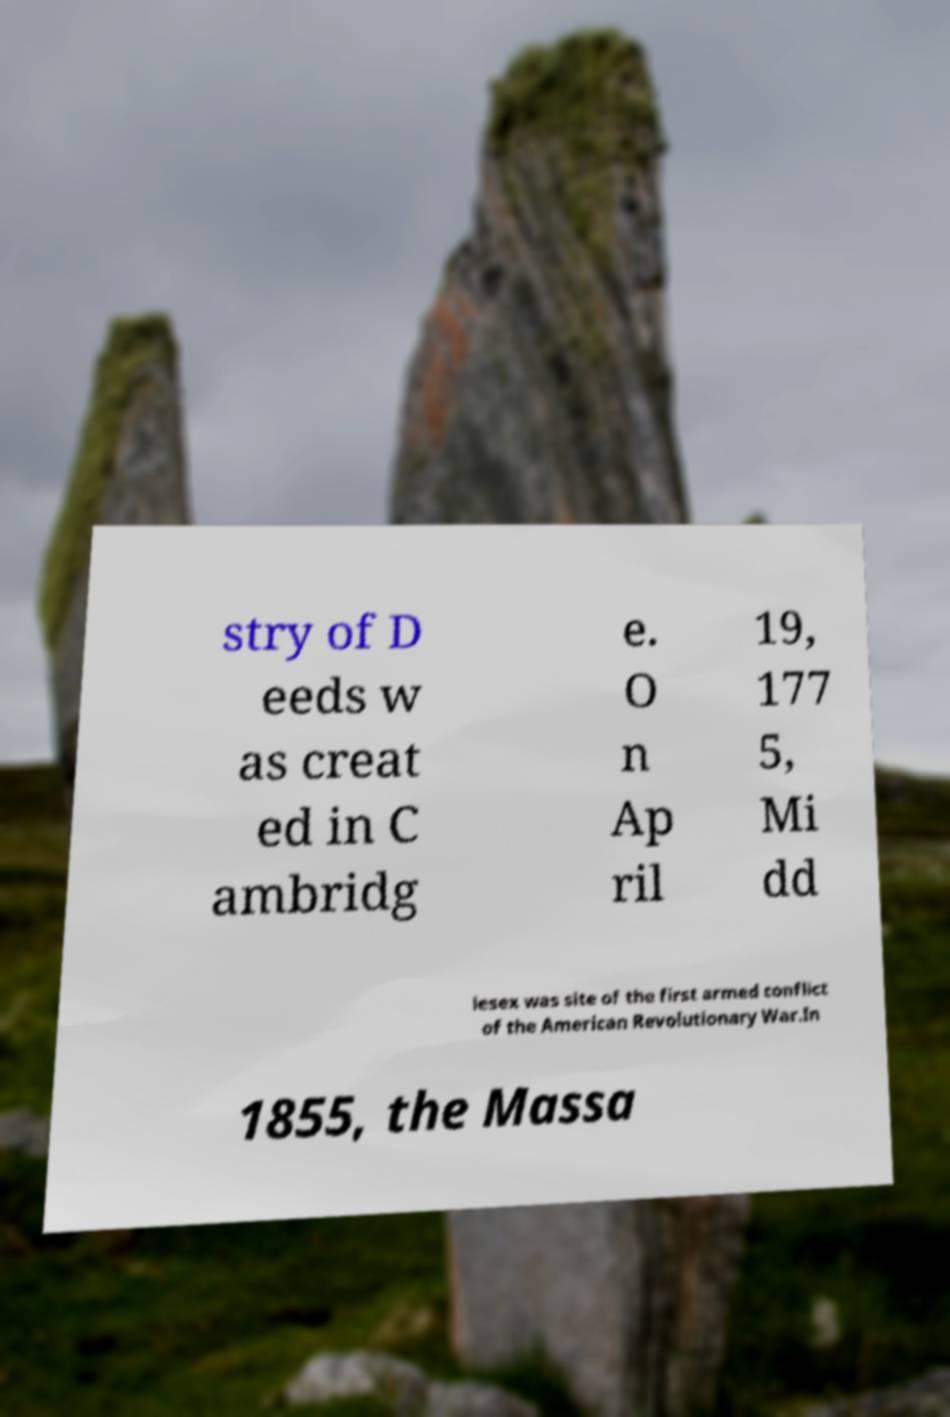Please read and relay the text visible in this image. What does it say? stry of D eeds w as creat ed in C ambridg e. O n Ap ril 19, 177 5, Mi dd lesex was site of the first armed conflict of the American Revolutionary War.In 1855, the Massa 